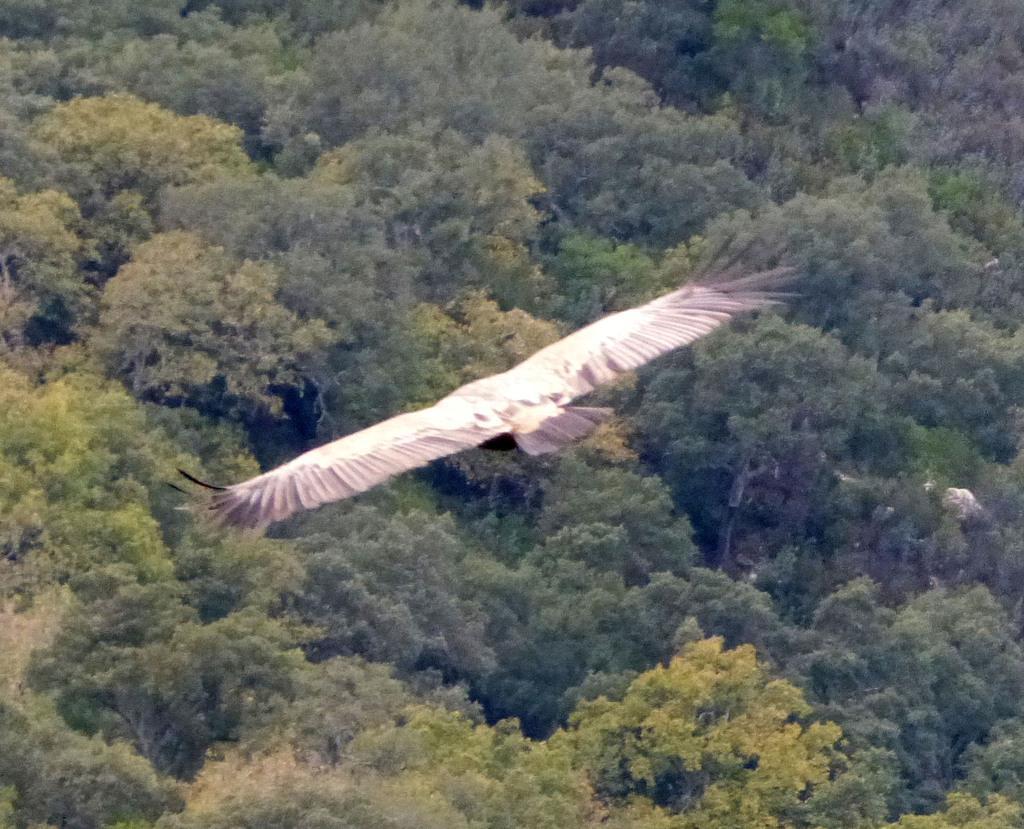Describe this image in one or two sentences. In this picture we can see a bird flying in the air and in the background we can see trees. 